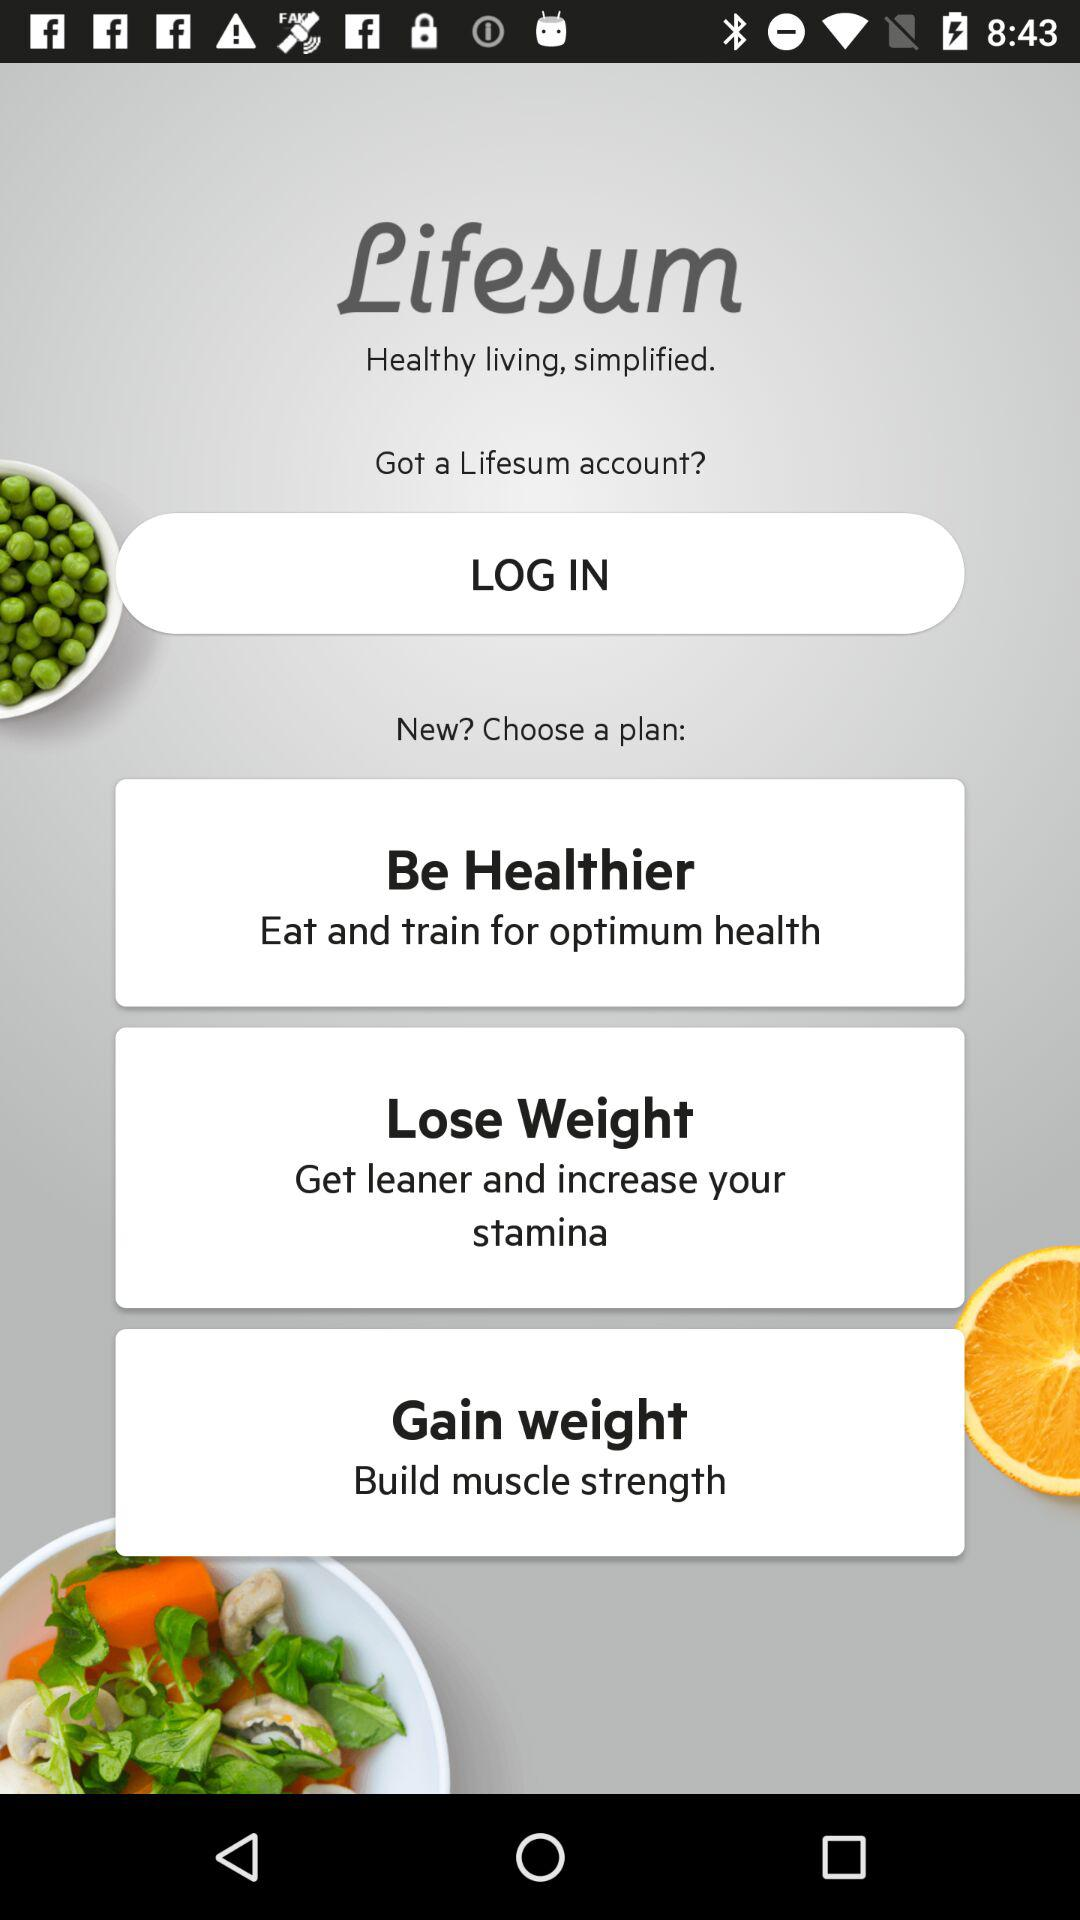"Be Healthier" is helpful for what? It is helpful for "optimum health". 